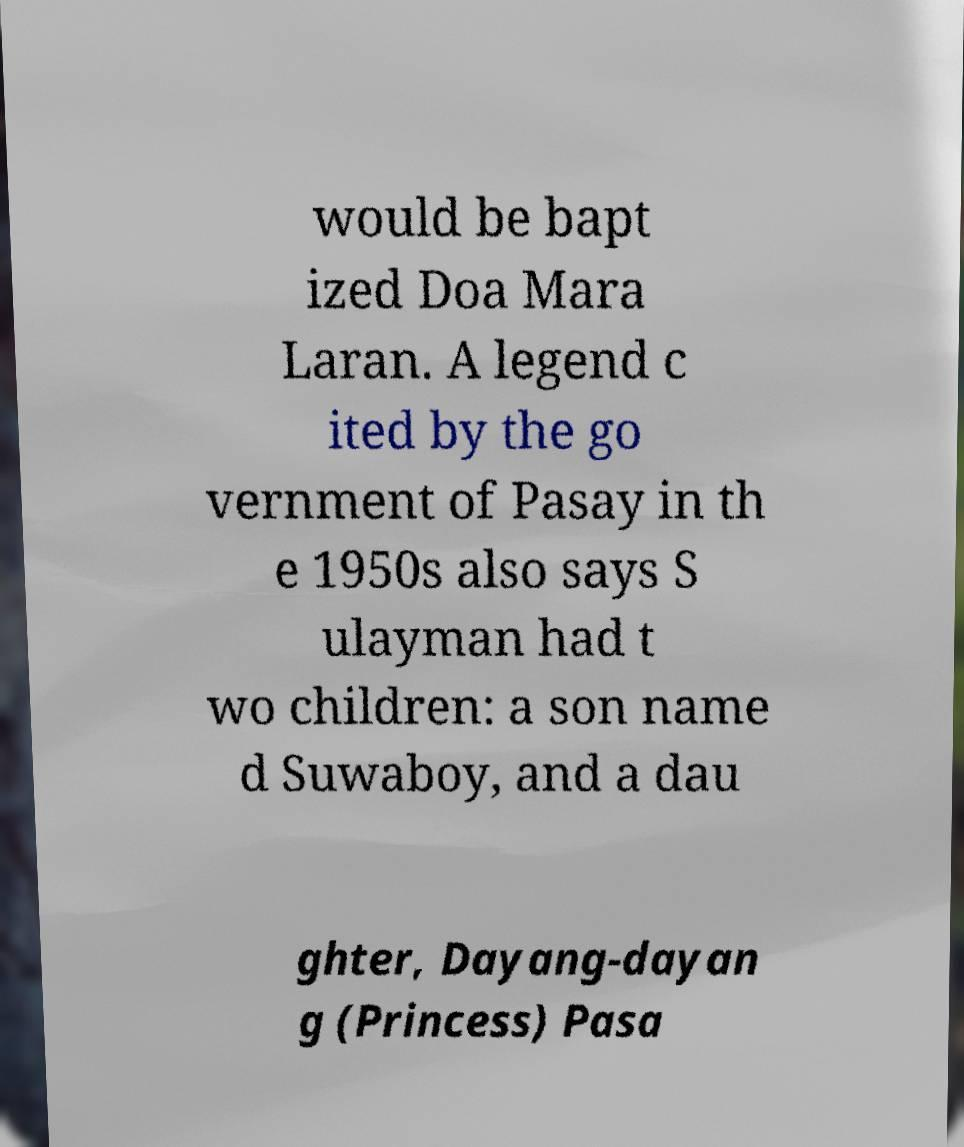Please identify and transcribe the text found in this image. would be bapt ized Doa Mara Laran. A legend c ited by the go vernment of Pasay in th e 1950s also says S ulayman had t wo children: a son name d Suwaboy, and a dau ghter, Dayang-dayan g (Princess) Pasa 